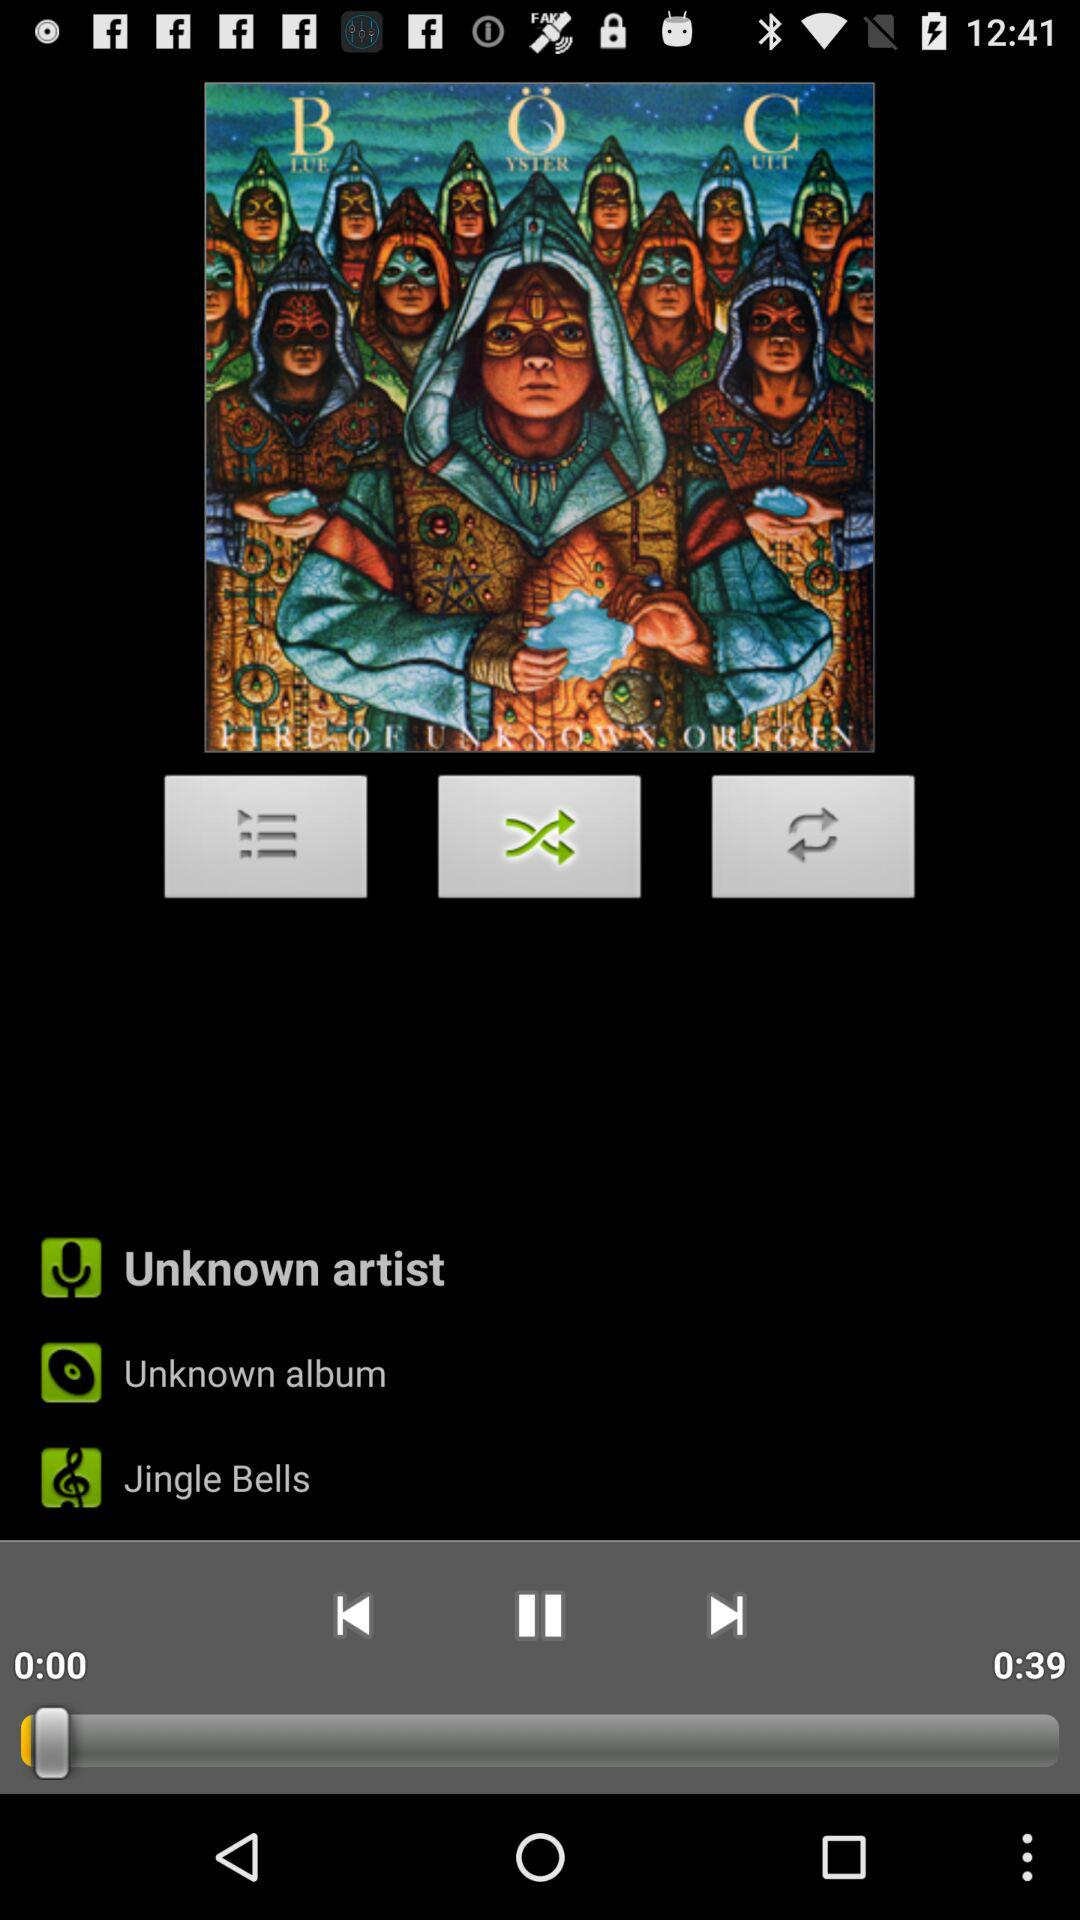What is the duration of the song that the person is currently playing? The duration of the song is 39 seconds. 